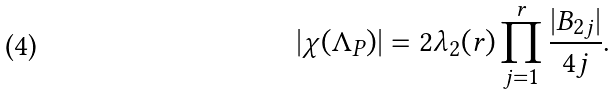Convert formula to latex. <formula><loc_0><loc_0><loc_500><loc_500>| \chi ( \Lambda _ { P } ) | & = 2 \lambda _ { 2 } ( r ) \prod _ { j = 1 } ^ { r } \frac { | B _ { 2 j } | } { 4 j } .</formula> 